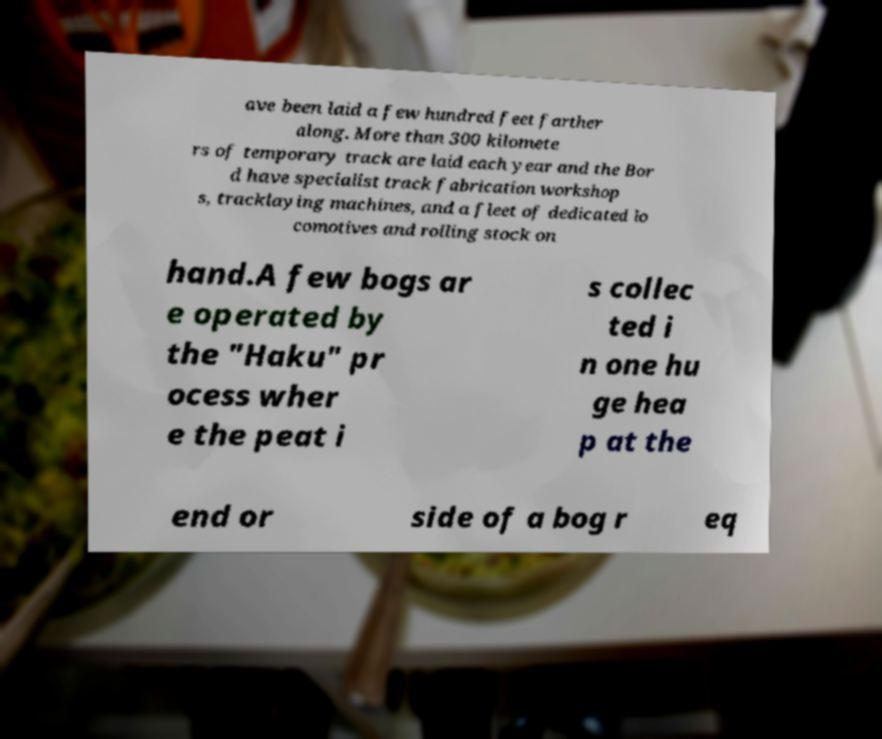There's text embedded in this image that I need extracted. Can you transcribe it verbatim? ave been laid a few hundred feet farther along. More than 300 kilomete rs of temporary track are laid each year and the Bor d have specialist track fabrication workshop s, tracklaying machines, and a fleet of dedicated lo comotives and rolling stock on hand.A few bogs ar e operated by the "Haku" pr ocess wher e the peat i s collec ted i n one hu ge hea p at the end or side of a bog r eq 